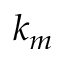<formula> <loc_0><loc_0><loc_500><loc_500>k _ { m }</formula> 